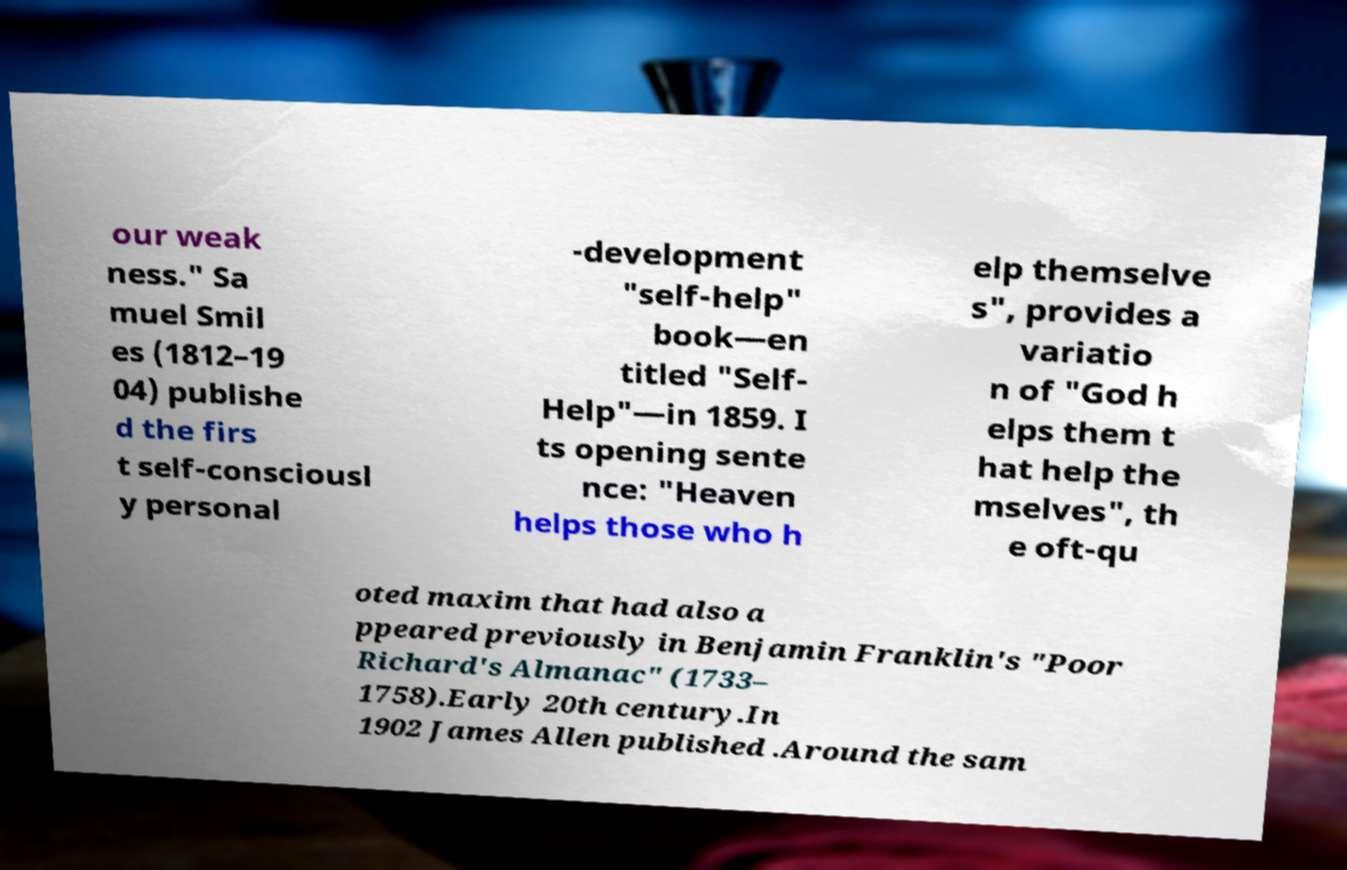I need the written content from this picture converted into text. Can you do that? our weak ness." Sa muel Smil es (1812–19 04) publishe d the firs t self-consciousl y personal -development "self-help" book—en titled "Self- Help"—in 1859. I ts opening sente nce: "Heaven helps those who h elp themselve s", provides a variatio n of "God h elps them t hat help the mselves", th e oft-qu oted maxim that had also a ppeared previously in Benjamin Franklin's "Poor Richard's Almanac" (1733– 1758).Early 20th century.In 1902 James Allen published .Around the sam 